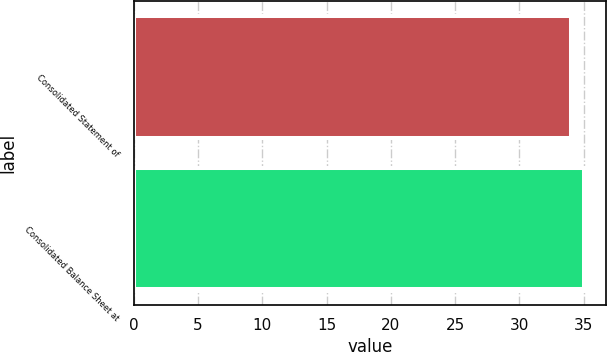Convert chart. <chart><loc_0><loc_0><loc_500><loc_500><bar_chart><fcel>Consolidated Statement of<fcel>Consolidated Balance Sheet at<nl><fcel>34<fcel>35<nl></chart> 